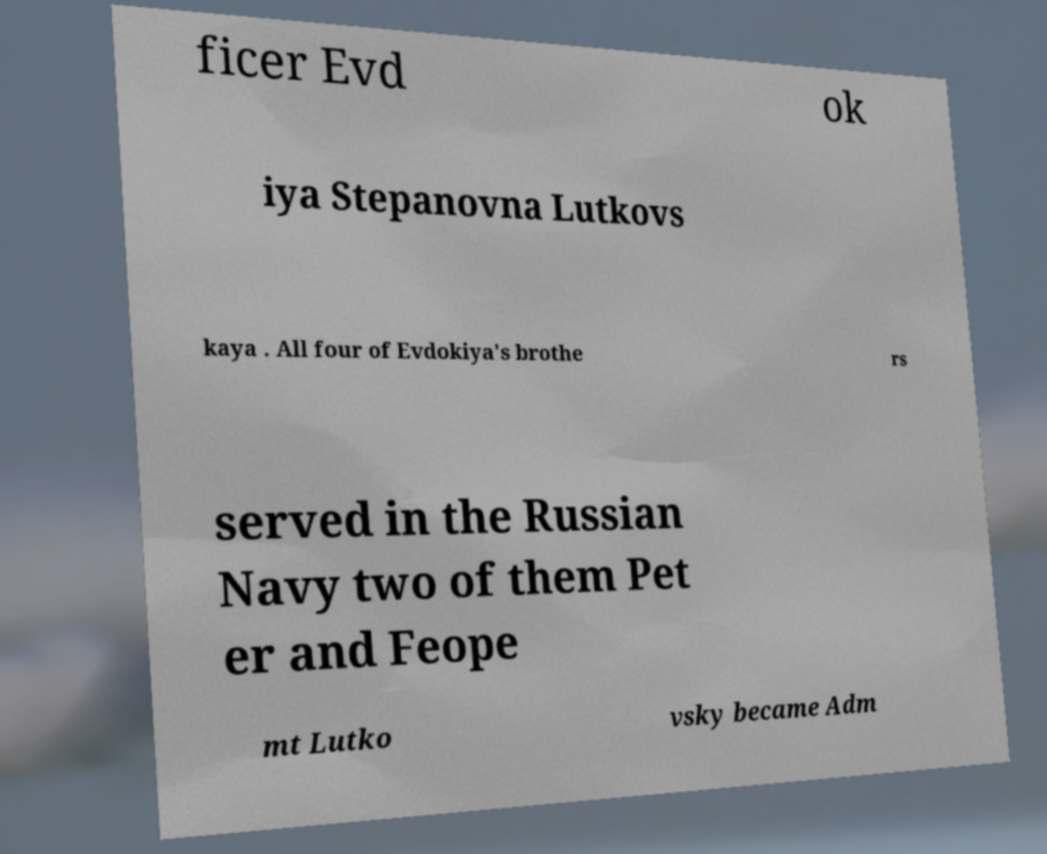Can you read and provide the text displayed in the image?This photo seems to have some interesting text. Can you extract and type it out for me? ficer Evd ok iya Stepanovna Lutkovs kaya . All four of Evdokiya's brothe rs served in the Russian Navy two of them Pet er and Feope mt Lutko vsky became Adm 